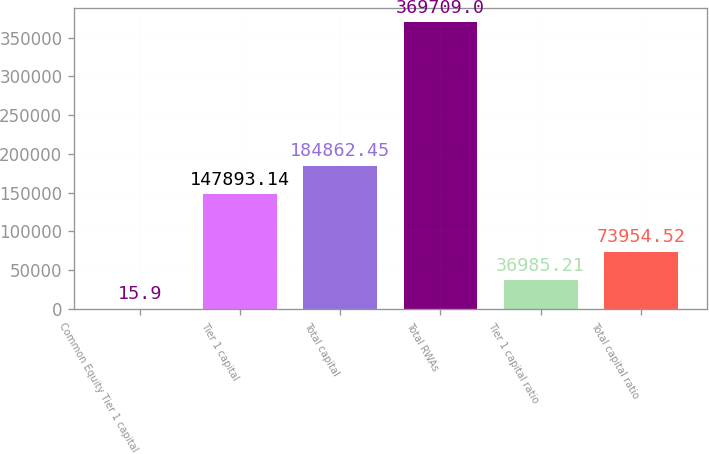Convert chart to OTSL. <chart><loc_0><loc_0><loc_500><loc_500><bar_chart><fcel>Common Equity Tier 1 capital<fcel>Tier 1 capital<fcel>Total capital<fcel>Total RWAs<fcel>Tier 1 capital ratio<fcel>Total capital ratio<nl><fcel>15.9<fcel>147893<fcel>184862<fcel>369709<fcel>36985.2<fcel>73954.5<nl></chart> 